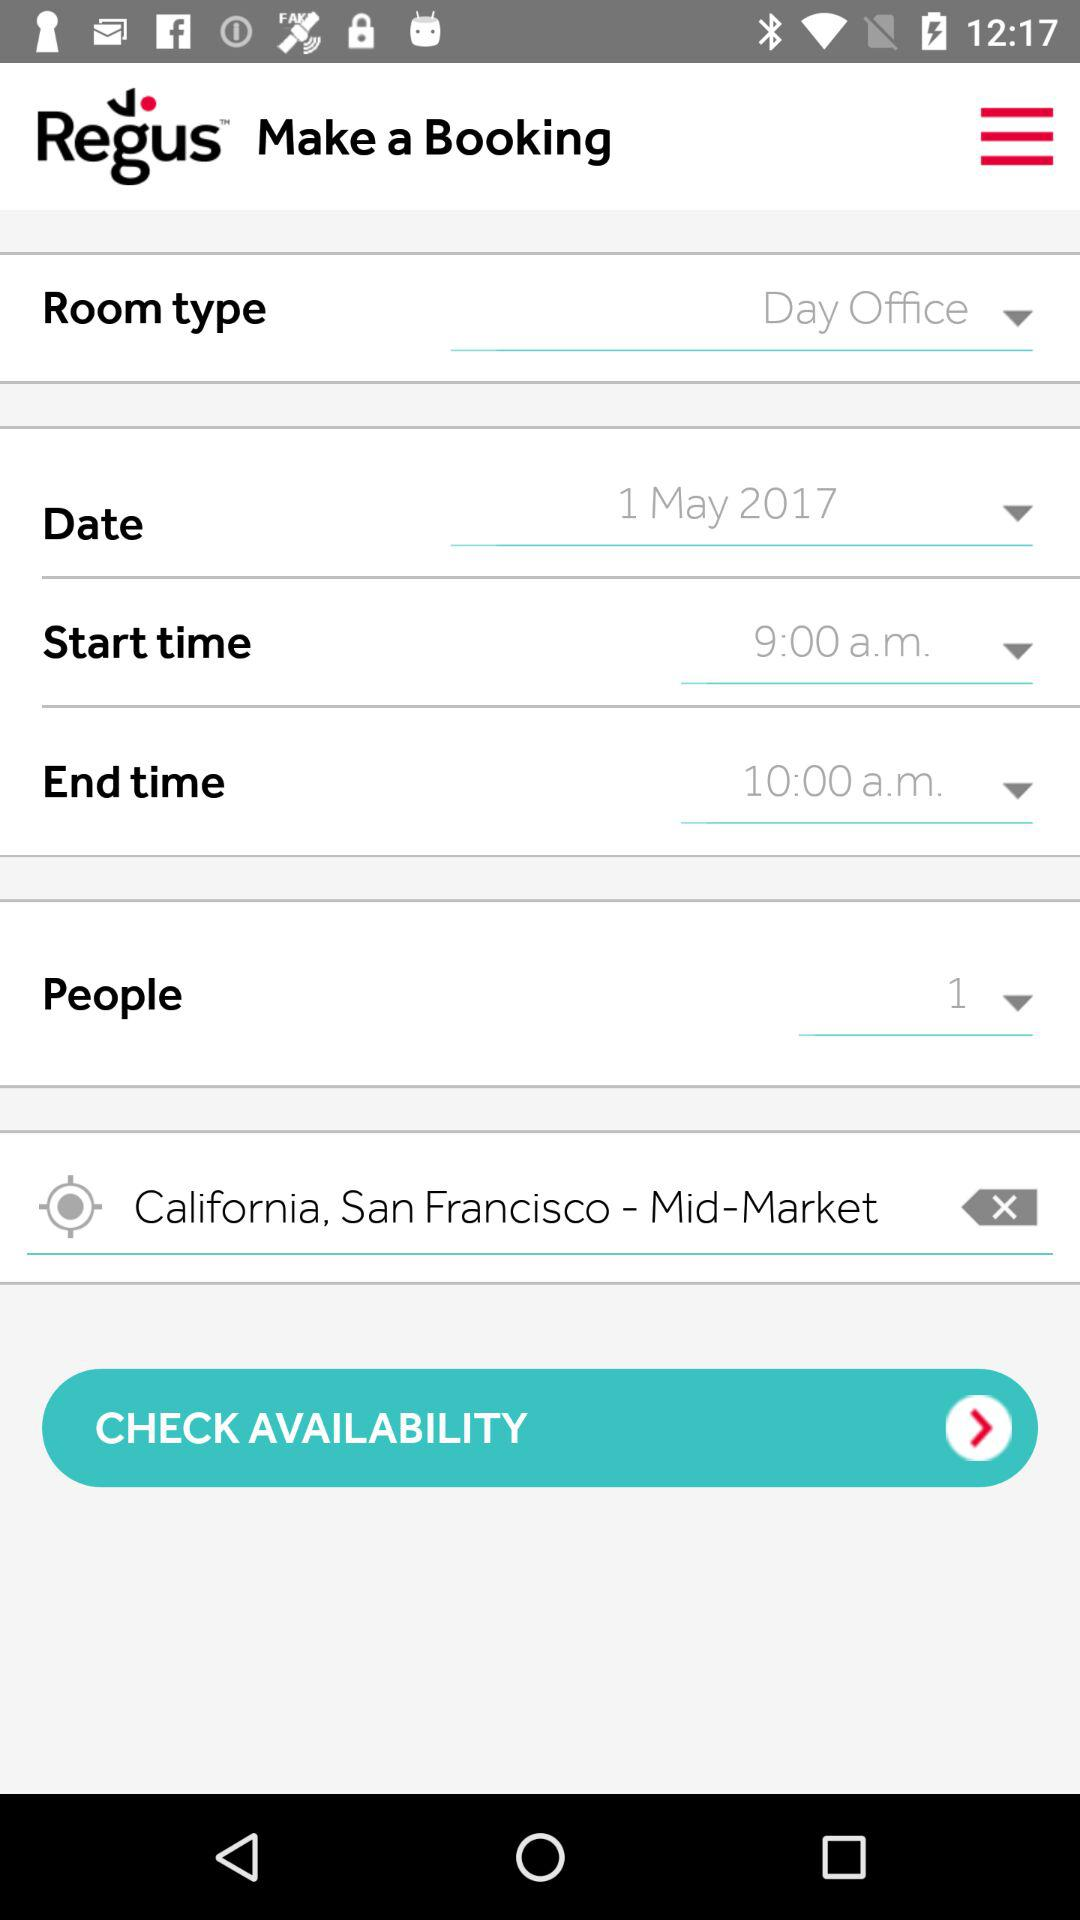How many people are booking the room?
Answer the question using a single word or phrase. 1 